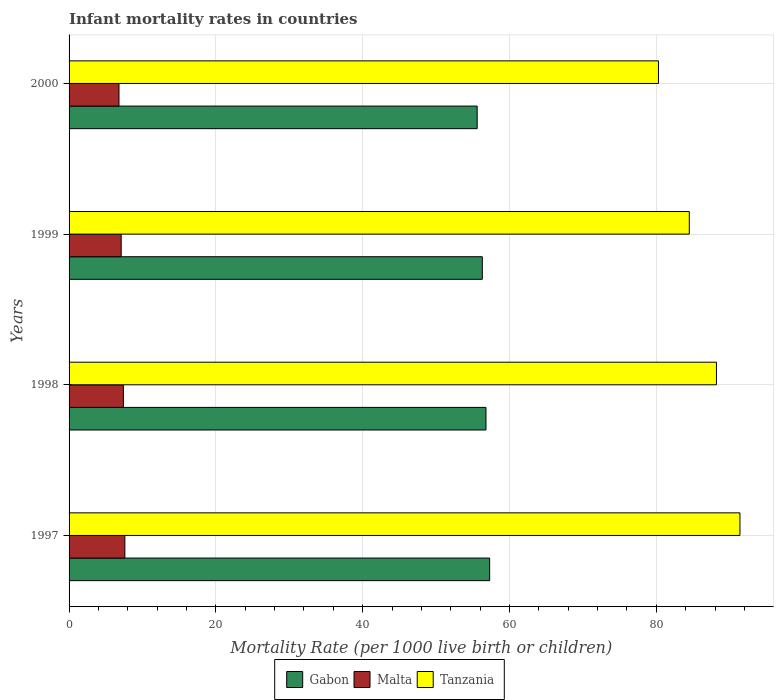How many groups of bars are there?
Your answer should be very brief. 4. What is the label of the 4th group of bars from the top?
Your answer should be compact. 1997. What is the infant mortality rate in Tanzania in 1998?
Make the answer very short. 88.2. Across all years, what is the minimum infant mortality rate in Gabon?
Offer a very short reply. 55.6. In which year was the infant mortality rate in Tanzania maximum?
Your response must be concise. 1997. What is the total infant mortality rate in Malta in the graph?
Your answer should be compact. 28.9. What is the difference between the infant mortality rate in Tanzania in 1997 and that in 2000?
Your answer should be compact. 11.1. What is the difference between the infant mortality rate in Tanzania in 2000 and the infant mortality rate in Malta in 1997?
Make the answer very short. 72.7. What is the average infant mortality rate in Gabon per year?
Ensure brevity in your answer.  56.5. In the year 1998, what is the difference between the infant mortality rate in Malta and infant mortality rate in Tanzania?
Make the answer very short. -80.8. What is the ratio of the infant mortality rate in Tanzania in 1999 to that in 2000?
Make the answer very short. 1.05. Is the infant mortality rate in Gabon in 1998 less than that in 2000?
Ensure brevity in your answer.  No. Is the difference between the infant mortality rate in Malta in 1999 and 2000 greater than the difference between the infant mortality rate in Tanzania in 1999 and 2000?
Your answer should be very brief. No. What is the difference between the highest and the second highest infant mortality rate in Malta?
Provide a succinct answer. 0.2. What is the difference between the highest and the lowest infant mortality rate in Gabon?
Ensure brevity in your answer.  1.7. Is the sum of the infant mortality rate in Malta in 1998 and 1999 greater than the maximum infant mortality rate in Gabon across all years?
Make the answer very short. No. What does the 3rd bar from the top in 1997 represents?
Keep it short and to the point. Gabon. What does the 2nd bar from the bottom in 1998 represents?
Your answer should be very brief. Malta. How many bars are there?
Provide a short and direct response. 12. How many years are there in the graph?
Ensure brevity in your answer.  4. Are the values on the major ticks of X-axis written in scientific E-notation?
Ensure brevity in your answer.  No. Does the graph contain any zero values?
Keep it short and to the point. No. Where does the legend appear in the graph?
Keep it short and to the point. Bottom center. What is the title of the graph?
Your answer should be compact. Infant mortality rates in countries. What is the label or title of the X-axis?
Offer a terse response. Mortality Rate (per 1000 live birth or children). What is the label or title of the Y-axis?
Provide a short and direct response. Years. What is the Mortality Rate (per 1000 live birth or children) of Gabon in 1997?
Your answer should be very brief. 57.3. What is the Mortality Rate (per 1000 live birth or children) in Tanzania in 1997?
Ensure brevity in your answer.  91.4. What is the Mortality Rate (per 1000 live birth or children) of Gabon in 1998?
Provide a short and direct response. 56.8. What is the Mortality Rate (per 1000 live birth or children) in Malta in 1998?
Offer a very short reply. 7.4. What is the Mortality Rate (per 1000 live birth or children) in Tanzania in 1998?
Make the answer very short. 88.2. What is the Mortality Rate (per 1000 live birth or children) in Gabon in 1999?
Your answer should be very brief. 56.3. What is the Mortality Rate (per 1000 live birth or children) in Tanzania in 1999?
Your answer should be compact. 84.5. What is the Mortality Rate (per 1000 live birth or children) in Gabon in 2000?
Give a very brief answer. 55.6. What is the Mortality Rate (per 1000 live birth or children) of Tanzania in 2000?
Your answer should be very brief. 80.3. Across all years, what is the maximum Mortality Rate (per 1000 live birth or children) in Gabon?
Ensure brevity in your answer.  57.3. Across all years, what is the maximum Mortality Rate (per 1000 live birth or children) of Tanzania?
Provide a succinct answer. 91.4. Across all years, what is the minimum Mortality Rate (per 1000 live birth or children) of Gabon?
Keep it short and to the point. 55.6. Across all years, what is the minimum Mortality Rate (per 1000 live birth or children) in Malta?
Offer a terse response. 6.8. Across all years, what is the minimum Mortality Rate (per 1000 live birth or children) in Tanzania?
Offer a very short reply. 80.3. What is the total Mortality Rate (per 1000 live birth or children) of Gabon in the graph?
Offer a terse response. 226. What is the total Mortality Rate (per 1000 live birth or children) in Malta in the graph?
Keep it short and to the point. 28.9. What is the total Mortality Rate (per 1000 live birth or children) of Tanzania in the graph?
Your response must be concise. 344.4. What is the difference between the Mortality Rate (per 1000 live birth or children) in Gabon in 1997 and that in 1999?
Make the answer very short. 1. What is the difference between the Mortality Rate (per 1000 live birth or children) of Tanzania in 1997 and that in 2000?
Ensure brevity in your answer.  11.1. What is the difference between the Mortality Rate (per 1000 live birth or children) of Malta in 1998 and that in 1999?
Your response must be concise. 0.3. What is the difference between the Mortality Rate (per 1000 live birth or children) of Tanzania in 1998 and that in 1999?
Offer a very short reply. 3.7. What is the difference between the Mortality Rate (per 1000 live birth or children) of Gabon in 1998 and that in 2000?
Provide a short and direct response. 1.2. What is the difference between the Mortality Rate (per 1000 live birth or children) of Malta in 1998 and that in 2000?
Provide a succinct answer. 0.6. What is the difference between the Mortality Rate (per 1000 live birth or children) of Tanzania in 1998 and that in 2000?
Your answer should be very brief. 7.9. What is the difference between the Mortality Rate (per 1000 live birth or children) in Gabon in 1999 and that in 2000?
Provide a short and direct response. 0.7. What is the difference between the Mortality Rate (per 1000 live birth or children) in Gabon in 1997 and the Mortality Rate (per 1000 live birth or children) in Malta in 1998?
Provide a short and direct response. 49.9. What is the difference between the Mortality Rate (per 1000 live birth or children) of Gabon in 1997 and the Mortality Rate (per 1000 live birth or children) of Tanzania in 1998?
Give a very brief answer. -30.9. What is the difference between the Mortality Rate (per 1000 live birth or children) of Malta in 1997 and the Mortality Rate (per 1000 live birth or children) of Tanzania in 1998?
Provide a short and direct response. -80.6. What is the difference between the Mortality Rate (per 1000 live birth or children) of Gabon in 1997 and the Mortality Rate (per 1000 live birth or children) of Malta in 1999?
Your answer should be very brief. 50.2. What is the difference between the Mortality Rate (per 1000 live birth or children) in Gabon in 1997 and the Mortality Rate (per 1000 live birth or children) in Tanzania in 1999?
Offer a very short reply. -27.2. What is the difference between the Mortality Rate (per 1000 live birth or children) in Malta in 1997 and the Mortality Rate (per 1000 live birth or children) in Tanzania in 1999?
Give a very brief answer. -76.9. What is the difference between the Mortality Rate (per 1000 live birth or children) in Gabon in 1997 and the Mortality Rate (per 1000 live birth or children) in Malta in 2000?
Your answer should be very brief. 50.5. What is the difference between the Mortality Rate (per 1000 live birth or children) of Gabon in 1997 and the Mortality Rate (per 1000 live birth or children) of Tanzania in 2000?
Give a very brief answer. -23. What is the difference between the Mortality Rate (per 1000 live birth or children) of Malta in 1997 and the Mortality Rate (per 1000 live birth or children) of Tanzania in 2000?
Provide a succinct answer. -72.7. What is the difference between the Mortality Rate (per 1000 live birth or children) of Gabon in 1998 and the Mortality Rate (per 1000 live birth or children) of Malta in 1999?
Ensure brevity in your answer.  49.7. What is the difference between the Mortality Rate (per 1000 live birth or children) in Gabon in 1998 and the Mortality Rate (per 1000 live birth or children) in Tanzania in 1999?
Ensure brevity in your answer.  -27.7. What is the difference between the Mortality Rate (per 1000 live birth or children) of Malta in 1998 and the Mortality Rate (per 1000 live birth or children) of Tanzania in 1999?
Provide a succinct answer. -77.1. What is the difference between the Mortality Rate (per 1000 live birth or children) in Gabon in 1998 and the Mortality Rate (per 1000 live birth or children) in Tanzania in 2000?
Offer a terse response. -23.5. What is the difference between the Mortality Rate (per 1000 live birth or children) in Malta in 1998 and the Mortality Rate (per 1000 live birth or children) in Tanzania in 2000?
Offer a terse response. -72.9. What is the difference between the Mortality Rate (per 1000 live birth or children) of Gabon in 1999 and the Mortality Rate (per 1000 live birth or children) of Malta in 2000?
Provide a succinct answer. 49.5. What is the difference between the Mortality Rate (per 1000 live birth or children) in Malta in 1999 and the Mortality Rate (per 1000 live birth or children) in Tanzania in 2000?
Your answer should be compact. -73.2. What is the average Mortality Rate (per 1000 live birth or children) in Gabon per year?
Your response must be concise. 56.5. What is the average Mortality Rate (per 1000 live birth or children) of Malta per year?
Give a very brief answer. 7.22. What is the average Mortality Rate (per 1000 live birth or children) in Tanzania per year?
Your answer should be compact. 86.1. In the year 1997, what is the difference between the Mortality Rate (per 1000 live birth or children) of Gabon and Mortality Rate (per 1000 live birth or children) of Malta?
Keep it short and to the point. 49.7. In the year 1997, what is the difference between the Mortality Rate (per 1000 live birth or children) of Gabon and Mortality Rate (per 1000 live birth or children) of Tanzania?
Give a very brief answer. -34.1. In the year 1997, what is the difference between the Mortality Rate (per 1000 live birth or children) of Malta and Mortality Rate (per 1000 live birth or children) of Tanzania?
Give a very brief answer. -83.8. In the year 1998, what is the difference between the Mortality Rate (per 1000 live birth or children) of Gabon and Mortality Rate (per 1000 live birth or children) of Malta?
Your answer should be very brief. 49.4. In the year 1998, what is the difference between the Mortality Rate (per 1000 live birth or children) of Gabon and Mortality Rate (per 1000 live birth or children) of Tanzania?
Ensure brevity in your answer.  -31.4. In the year 1998, what is the difference between the Mortality Rate (per 1000 live birth or children) of Malta and Mortality Rate (per 1000 live birth or children) of Tanzania?
Give a very brief answer. -80.8. In the year 1999, what is the difference between the Mortality Rate (per 1000 live birth or children) in Gabon and Mortality Rate (per 1000 live birth or children) in Malta?
Your response must be concise. 49.2. In the year 1999, what is the difference between the Mortality Rate (per 1000 live birth or children) in Gabon and Mortality Rate (per 1000 live birth or children) in Tanzania?
Offer a very short reply. -28.2. In the year 1999, what is the difference between the Mortality Rate (per 1000 live birth or children) in Malta and Mortality Rate (per 1000 live birth or children) in Tanzania?
Your response must be concise. -77.4. In the year 2000, what is the difference between the Mortality Rate (per 1000 live birth or children) of Gabon and Mortality Rate (per 1000 live birth or children) of Malta?
Your answer should be very brief. 48.8. In the year 2000, what is the difference between the Mortality Rate (per 1000 live birth or children) of Gabon and Mortality Rate (per 1000 live birth or children) of Tanzania?
Offer a very short reply. -24.7. In the year 2000, what is the difference between the Mortality Rate (per 1000 live birth or children) of Malta and Mortality Rate (per 1000 live birth or children) of Tanzania?
Keep it short and to the point. -73.5. What is the ratio of the Mortality Rate (per 1000 live birth or children) in Gabon in 1997 to that in 1998?
Offer a terse response. 1.01. What is the ratio of the Mortality Rate (per 1000 live birth or children) of Tanzania in 1997 to that in 1998?
Your response must be concise. 1.04. What is the ratio of the Mortality Rate (per 1000 live birth or children) in Gabon in 1997 to that in 1999?
Offer a very short reply. 1.02. What is the ratio of the Mortality Rate (per 1000 live birth or children) of Malta in 1997 to that in 1999?
Provide a short and direct response. 1.07. What is the ratio of the Mortality Rate (per 1000 live birth or children) in Tanzania in 1997 to that in 1999?
Provide a succinct answer. 1.08. What is the ratio of the Mortality Rate (per 1000 live birth or children) of Gabon in 1997 to that in 2000?
Your response must be concise. 1.03. What is the ratio of the Mortality Rate (per 1000 live birth or children) of Malta in 1997 to that in 2000?
Offer a terse response. 1.12. What is the ratio of the Mortality Rate (per 1000 live birth or children) of Tanzania in 1997 to that in 2000?
Offer a very short reply. 1.14. What is the ratio of the Mortality Rate (per 1000 live birth or children) in Gabon in 1998 to that in 1999?
Provide a short and direct response. 1.01. What is the ratio of the Mortality Rate (per 1000 live birth or children) in Malta in 1998 to that in 1999?
Keep it short and to the point. 1.04. What is the ratio of the Mortality Rate (per 1000 live birth or children) in Tanzania in 1998 to that in 1999?
Make the answer very short. 1.04. What is the ratio of the Mortality Rate (per 1000 live birth or children) in Gabon in 1998 to that in 2000?
Make the answer very short. 1.02. What is the ratio of the Mortality Rate (per 1000 live birth or children) in Malta in 1998 to that in 2000?
Offer a very short reply. 1.09. What is the ratio of the Mortality Rate (per 1000 live birth or children) in Tanzania in 1998 to that in 2000?
Your answer should be very brief. 1.1. What is the ratio of the Mortality Rate (per 1000 live birth or children) in Gabon in 1999 to that in 2000?
Make the answer very short. 1.01. What is the ratio of the Mortality Rate (per 1000 live birth or children) in Malta in 1999 to that in 2000?
Keep it short and to the point. 1.04. What is the ratio of the Mortality Rate (per 1000 live birth or children) of Tanzania in 1999 to that in 2000?
Provide a succinct answer. 1.05. What is the difference between the highest and the second highest Mortality Rate (per 1000 live birth or children) in Tanzania?
Give a very brief answer. 3.2. What is the difference between the highest and the lowest Mortality Rate (per 1000 live birth or children) in Gabon?
Provide a succinct answer. 1.7. What is the difference between the highest and the lowest Mortality Rate (per 1000 live birth or children) of Malta?
Keep it short and to the point. 0.8. 